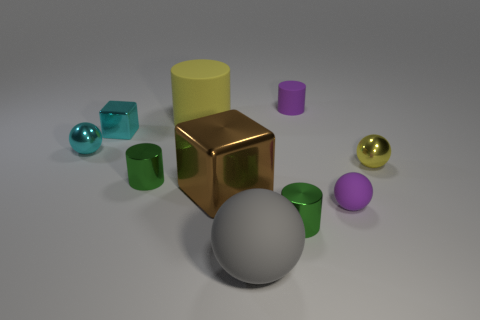Are the big yellow cylinder and the tiny cyan block that is on the right side of the tiny cyan ball made of the same material?
Keep it short and to the point. No. What number of large yellow objects are there?
Ensure brevity in your answer.  1. There is a rubber cylinder to the left of the gray rubber object; how big is it?
Offer a terse response. Large. How many yellow rubber cylinders have the same size as the gray matte thing?
Provide a succinct answer. 1. There is a ball that is behind the tiny purple rubber sphere and on the right side of the brown shiny block; what is its material?
Ensure brevity in your answer.  Metal. What material is the cube that is the same size as the gray matte thing?
Ensure brevity in your answer.  Metal. What is the size of the block that is in front of the small shiny sphere that is left of the big matte object behind the purple ball?
Ensure brevity in your answer.  Large. There is a gray sphere that is the same material as the big yellow thing; what is its size?
Keep it short and to the point. Large. Does the cyan metallic sphere have the same size as the cube that is in front of the small cyan metal block?
Keep it short and to the point. No. What shape is the big rubber object behind the tiny yellow metal sphere?
Keep it short and to the point. Cylinder. 